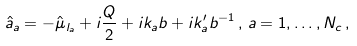Convert formula to latex. <formula><loc_0><loc_0><loc_500><loc_500>\hat { a } _ { a } = - \hat { \mu } _ { l _ { a } } + i \frac { Q } { 2 } + i k _ { a } b + i k ^ { \prime } _ { a } b ^ { - 1 } \, , \, a = 1 , \dots , N _ { c } \, ,</formula> 